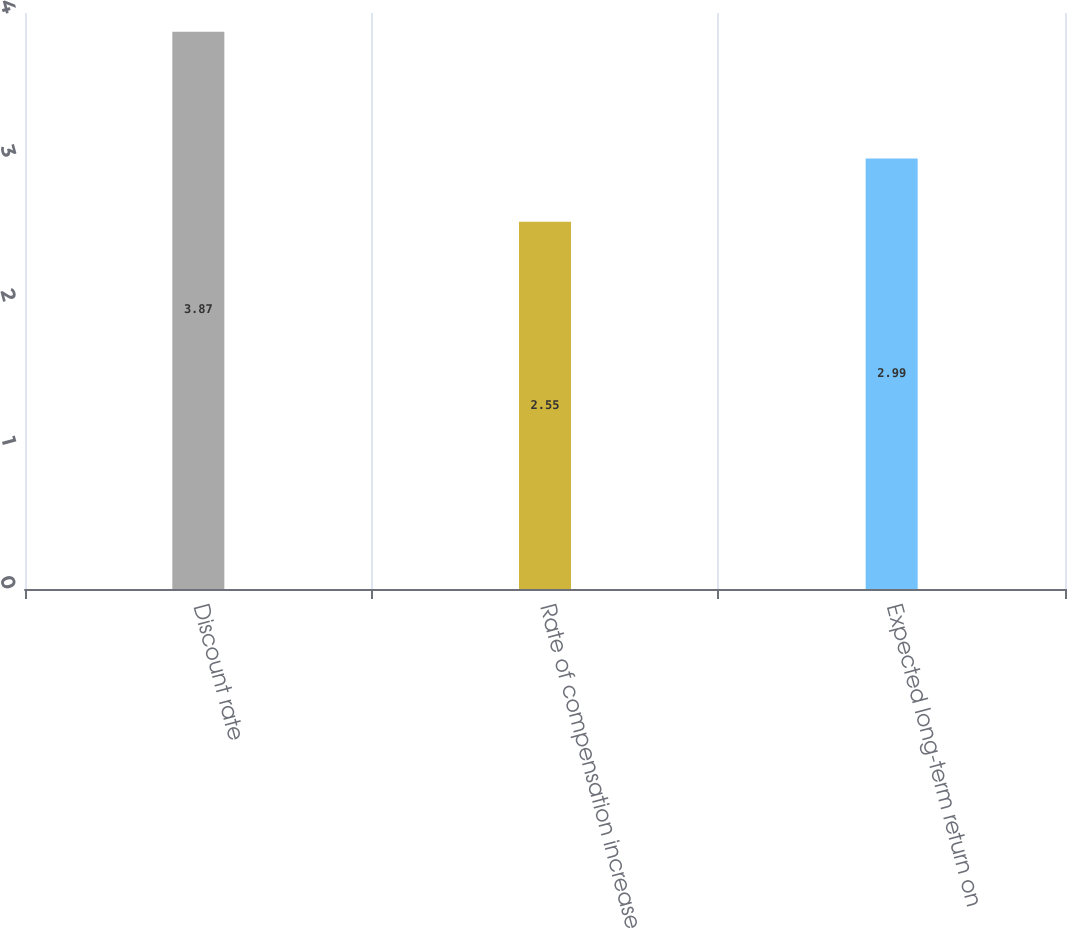Convert chart. <chart><loc_0><loc_0><loc_500><loc_500><bar_chart><fcel>Discount rate<fcel>Rate of compensation increase<fcel>Expected long-term return on<nl><fcel>3.87<fcel>2.55<fcel>2.99<nl></chart> 